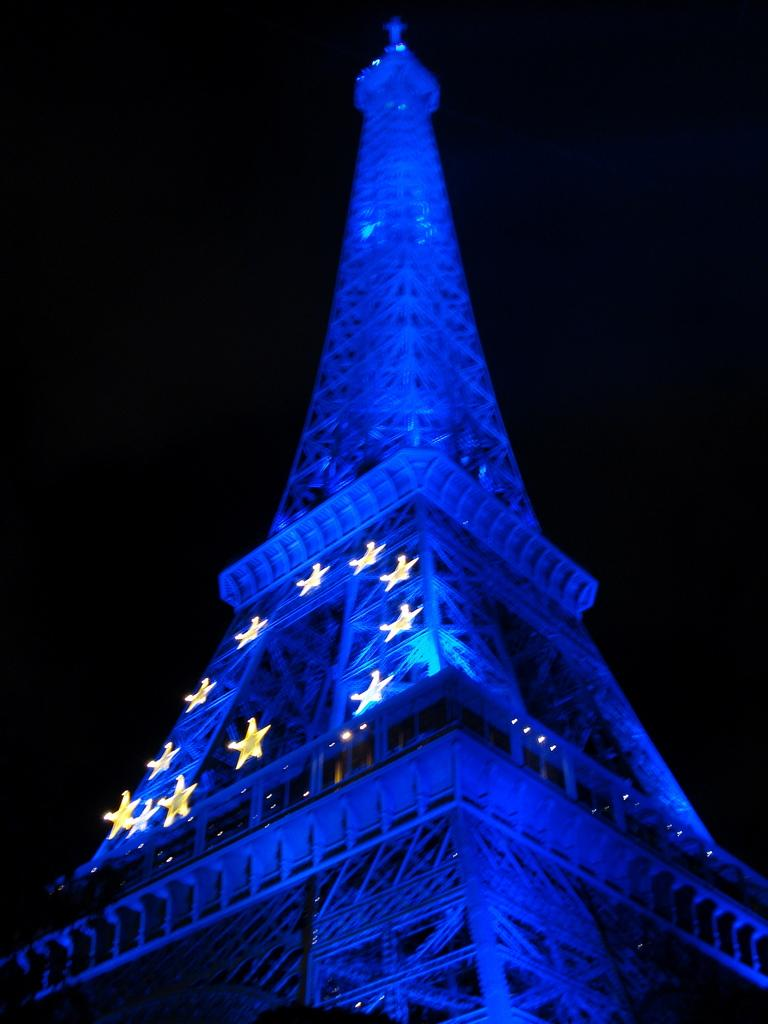What is the main subject of the image? The main subject of the image is a tower. Can you describe the background of the image? The background of the image is dark. How many corks are floating in the jar in the image? There is no jar or corks present in the image; it features a tower with a dark background. 